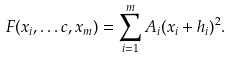Convert formula to latex. <formula><loc_0><loc_0><loc_500><loc_500>F ( x _ { i } , \dots c , x _ { m } ) = \sum _ { i = 1 } ^ { m } A _ { i } ( x _ { i } + h _ { i } ) ^ { 2 } .</formula> 